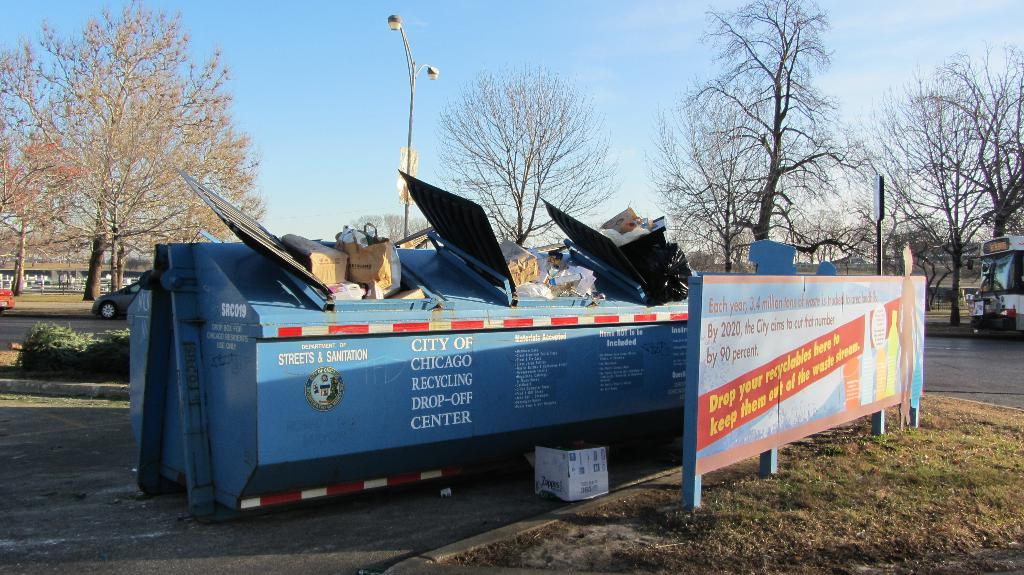Provide a one-sentence caption for the provided image. The Recycling Center drop off site in Chicago is full of recyclables. 